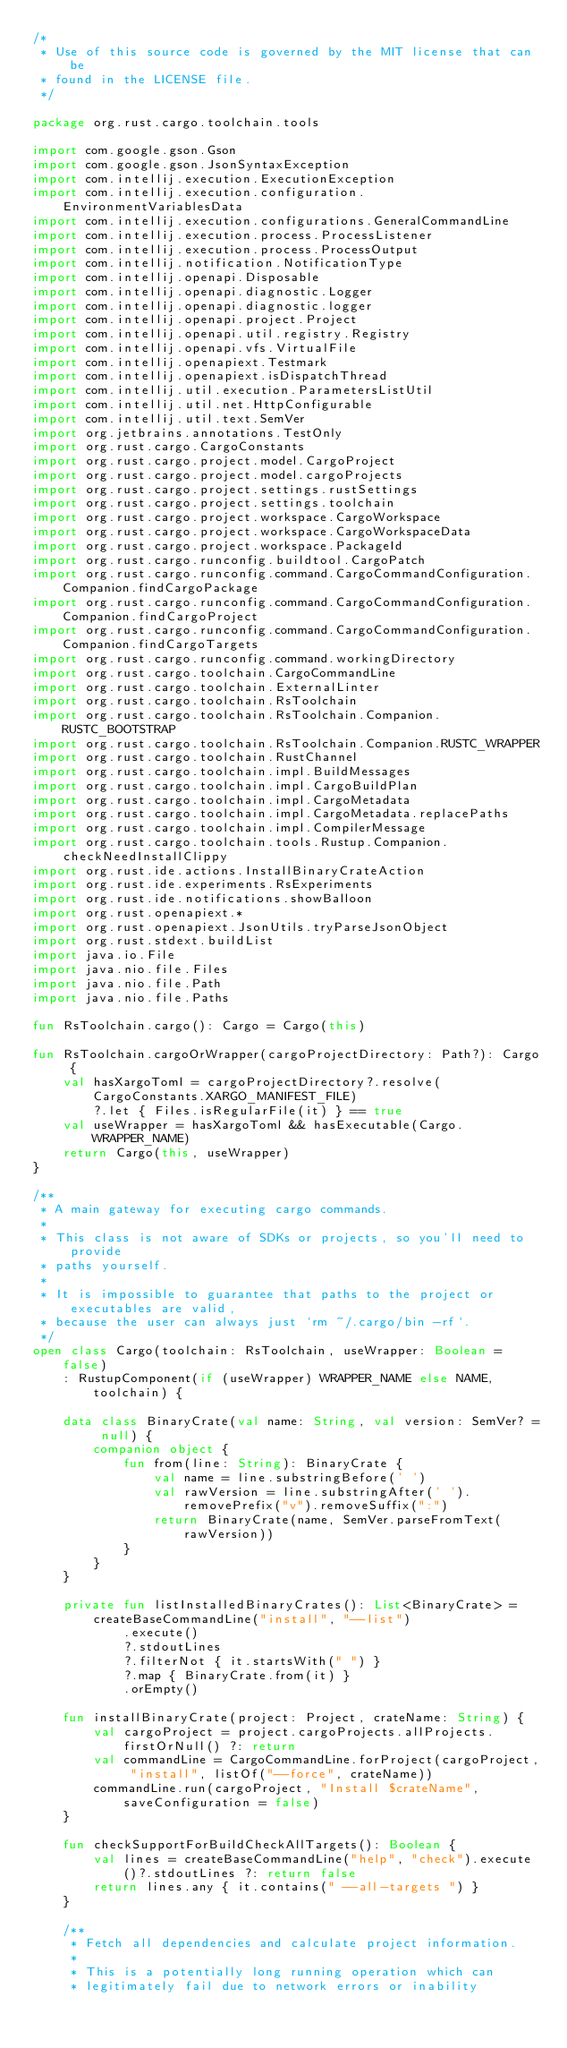<code> <loc_0><loc_0><loc_500><loc_500><_Kotlin_>/*
 * Use of this source code is governed by the MIT license that can be
 * found in the LICENSE file.
 */

package org.rust.cargo.toolchain.tools

import com.google.gson.Gson
import com.google.gson.JsonSyntaxException
import com.intellij.execution.ExecutionException
import com.intellij.execution.configuration.EnvironmentVariablesData
import com.intellij.execution.configurations.GeneralCommandLine
import com.intellij.execution.process.ProcessListener
import com.intellij.execution.process.ProcessOutput
import com.intellij.notification.NotificationType
import com.intellij.openapi.Disposable
import com.intellij.openapi.diagnostic.Logger
import com.intellij.openapi.diagnostic.logger
import com.intellij.openapi.project.Project
import com.intellij.openapi.util.registry.Registry
import com.intellij.openapi.vfs.VirtualFile
import com.intellij.openapiext.Testmark
import com.intellij.openapiext.isDispatchThread
import com.intellij.util.execution.ParametersListUtil
import com.intellij.util.net.HttpConfigurable
import com.intellij.util.text.SemVer
import org.jetbrains.annotations.TestOnly
import org.rust.cargo.CargoConstants
import org.rust.cargo.project.model.CargoProject
import org.rust.cargo.project.model.cargoProjects
import org.rust.cargo.project.settings.rustSettings
import org.rust.cargo.project.settings.toolchain
import org.rust.cargo.project.workspace.CargoWorkspace
import org.rust.cargo.project.workspace.CargoWorkspaceData
import org.rust.cargo.project.workspace.PackageId
import org.rust.cargo.runconfig.buildtool.CargoPatch
import org.rust.cargo.runconfig.command.CargoCommandConfiguration.Companion.findCargoPackage
import org.rust.cargo.runconfig.command.CargoCommandConfiguration.Companion.findCargoProject
import org.rust.cargo.runconfig.command.CargoCommandConfiguration.Companion.findCargoTargets
import org.rust.cargo.runconfig.command.workingDirectory
import org.rust.cargo.toolchain.CargoCommandLine
import org.rust.cargo.toolchain.ExternalLinter
import org.rust.cargo.toolchain.RsToolchain
import org.rust.cargo.toolchain.RsToolchain.Companion.RUSTC_BOOTSTRAP
import org.rust.cargo.toolchain.RsToolchain.Companion.RUSTC_WRAPPER
import org.rust.cargo.toolchain.RustChannel
import org.rust.cargo.toolchain.impl.BuildMessages
import org.rust.cargo.toolchain.impl.CargoBuildPlan
import org.rust.cargo.toolchain.impl.CargoMetadata
import org.rust.cargo.toolchain.impl.CargoMetadata.replacePaths
import org.rust.cargo.toolchain.impl.CompilerMessage
import org.rust.cargo.toolchain.tools.Rustup.Companion.checkNeedInstallClippy
import org.rust.ide.actions.InstallBinaryCrateAction
import org.rust.ide.experiments.RsExperiments
import org.rust.ide.notifications.showBalloon
import org.rust.openapiext.*
import org.rust.openapiext.JsonUtils.tryParseJsonObject
import org.rust.stdext.buildList
import java.io.File
import java.nio.file.Files
import java.nio.file.Path
import java.nio.file.Paths

fun RsToolchain.cargo(): Cargo = Cargo(this)

fun RsToolchain.cargoOrWrapper(cargoProjectDirectory: Path?): Cargo {
    val hasXargoToml = cargoProjectDirectory?.resolve(CargoConstants.XARGO_MANIFEST_FILE)
        ?.let { Files.isRegularFile(it) } == true
    val useWrapper = hasXargoToml && hasExecutable(Cargo.WRAPPER_NAME)
    return Cargo(this, useWrapper)
}

/**
 * A main gateway for executing cargo commands.
 *
 * This class is not aware of SDKs or projects, so you'll need to provide
 * paths yourself.
 *
 * It is impossible to guarantee that paths to the project or executables are valid,
 * because the user can always just `rm ~/.cargo/bin -rf`.
 */
open class Cargo(toolchain: RsToolchain, useWrapper: Boolean = false)
    : RustupComponent(if (useWrapper) WRAPPER_NAME else NAME, toolchain) {

    data class BinaryCrate(val name: String, val version: SemVer? = null) {
        companion object {
            fun from(line: String): BinaryCrate {
                val name = line.substringBefore(' ')
                val rawVersion = line.substringAfter(' ').removePrefix("v").removeSuffix(":")
                return BinaryCrate(name, SemVer.parseFromText(rawVersion))
            }
        }
    }

    private fun listInstalledBinaryCrates(): List<BinaryCrate> =
        createBaseCommandLine("install", "--list")
            .execute()
            ?.stdoutLines
            ?.filterNot { it.startsWith(" ") }
            ?.map { BinaryCrate.from(it) }
            .orEmpty()

    fun installBinaryCrate(project: Project, crateName: String) {
        val cargoProject = project.cargoProjects.allProjects.firstOrNull() ?: return
        val commandLine = CargoCommandLine.forProject(cargoProject, "install", listOf("--force", crateName))
        commandLine.run(cargoProject, "Install $crateName", saveConfiguration = false)
    }

    fun checkSupportForBuildCheckAllTargets(): Boolean {
        val lines = createBaseCommandLine("help", "check").execute()?.stdoutLines ?: return false
        return lines.any { it.contains(" --all-targets ") }
    }

    /**
     * Fetch all dependencies and calculate project information.
     *
     * This is a potentially long running operation which can
     * legitimately fail due to network errors or inability</code> 